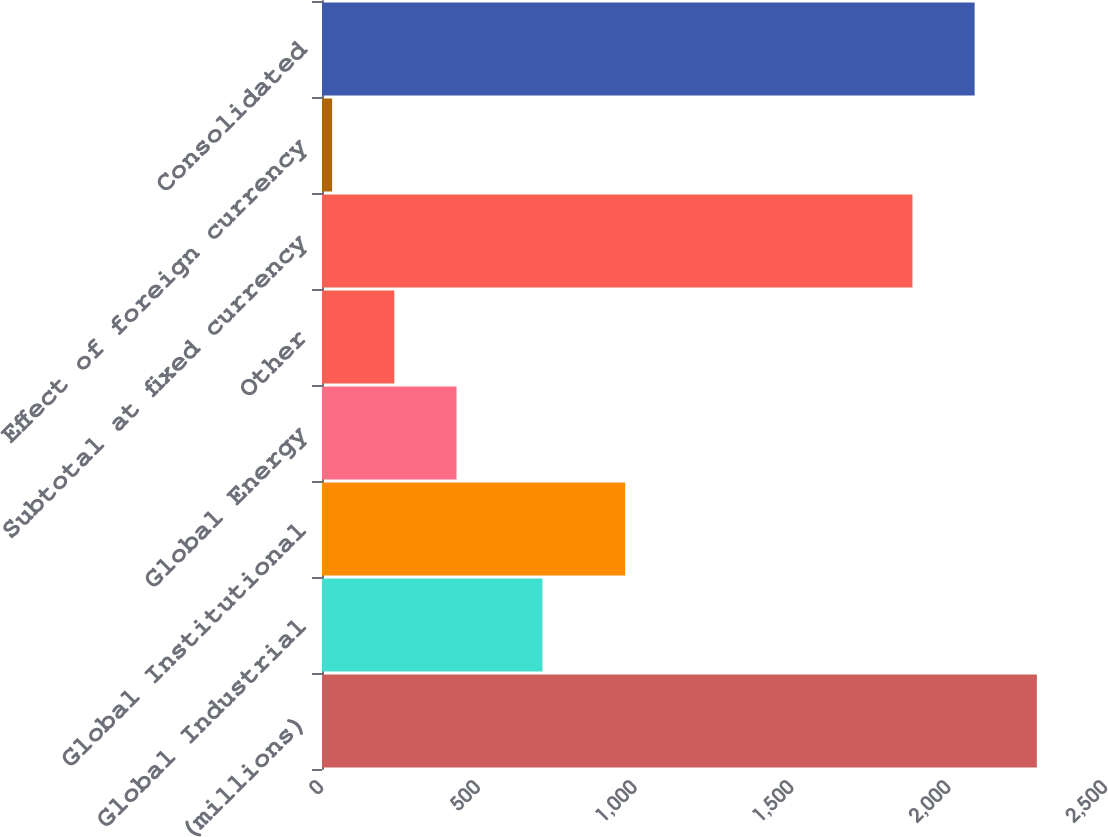Convert chart to OTSL. <chart><loc_0><loc_0><loc_500><loc_500><bar_chart><fcel>(millions)<fcel>Global Industrial<fcel>Global Institutional<fcel>Global Energy<fcel>Other<fcel>Subtotal at fixed currency<fcel>Effect of foreign currency<fcel>Consolidated<nl><fcel>2279.56<fcel>703<fcel>966.7<fcel>428.96<fcel>230.58<fcel>1882.8<fcel>32.2<fcel>2081.18<nl></chart> 